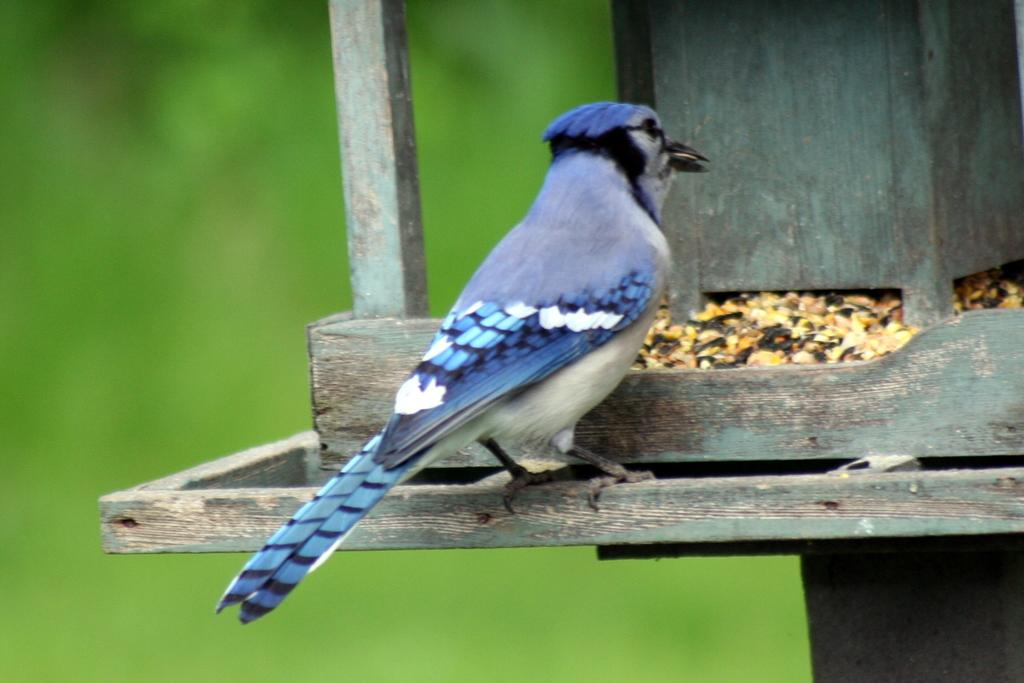What type of animal can be seen in the image? There is a bird in the image. What is the bird standing on? The bird is standing on a wooden object. How would you describe the background of the image? The background of the image appears green and is blurred. What type of throne is the bird sitting on in the image? There is no throne present in the image; the bird is standing on a wooden object. 